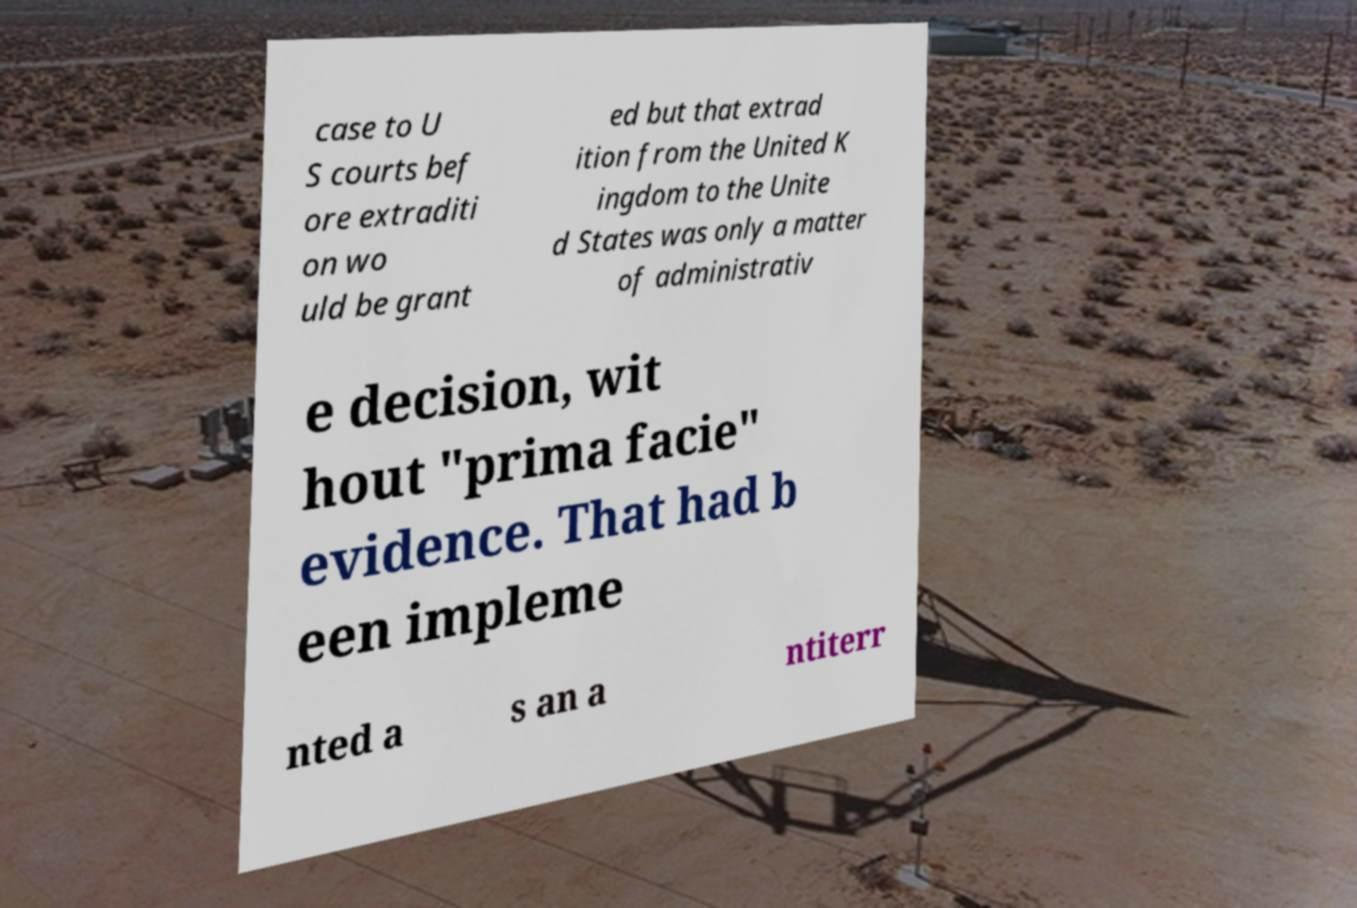There's text embedded in this image that I need extracted. Can you transcribe it verbatim? case to U S courts bef ore extraditi on wo uld be grant ed but that extrad ition from the United K ingdom to the Unite d States was only a matter of administrativ e decision, wit hout "prima facie" evidence. That had b een impleme nted a s an a ntiterr 